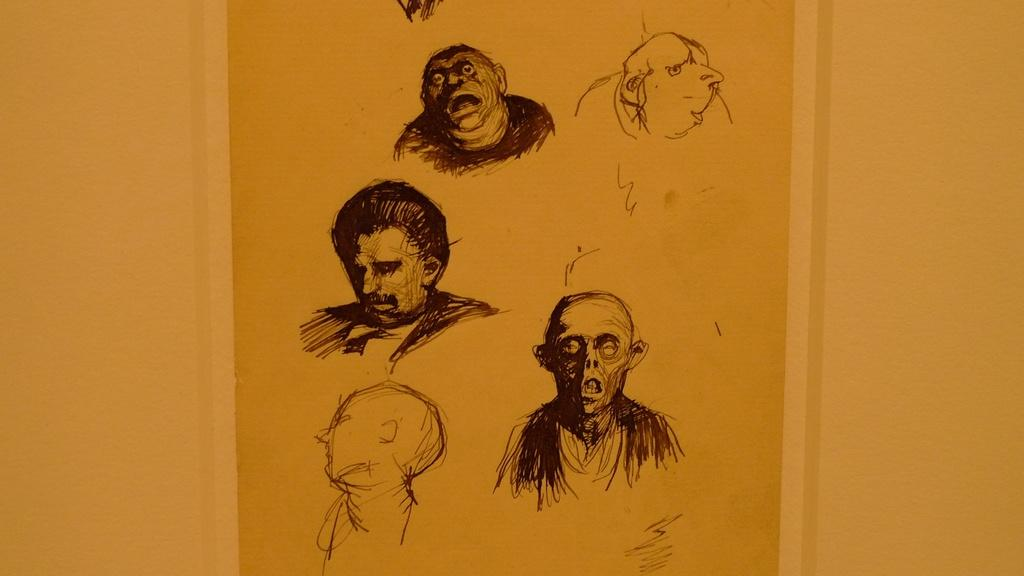What is the main subject of the image? There is a drawing in the center of the image. How much beef can be seen in the image? There is no beef present in the image; it features a drawing in the center. How many dimes are visible in the image? There are no dimes present in the image. 